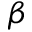<formula> <loc_0><loc_0><loc_500><loc_500>\beta</formula> 